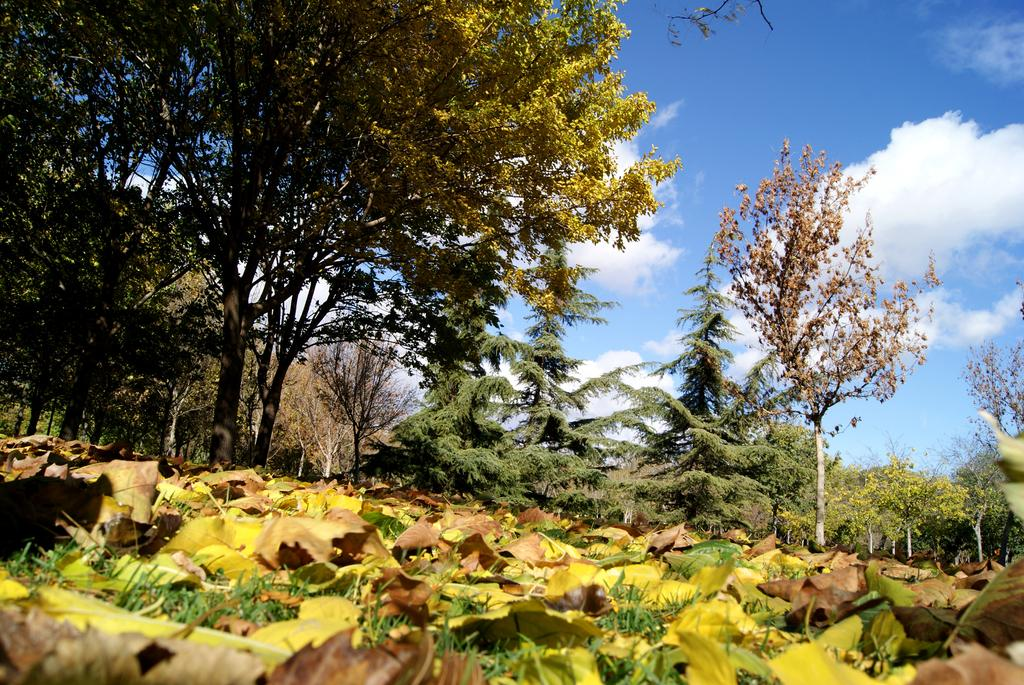What type of vegetation is located in the middle of the image? There are trees in the middle of the image. What other type of vegetation can be seen at the bottom of the image? There are plants at the bottom of the image. What is visible at the top of the image? The sky is visible at the top of the image. What instrument does the afterthought play in the image? There is no afterthought or instrument present in the image. Who is the achiever in the image? There is no achiever depicted in the image; it features trees, plants, and the sky. 